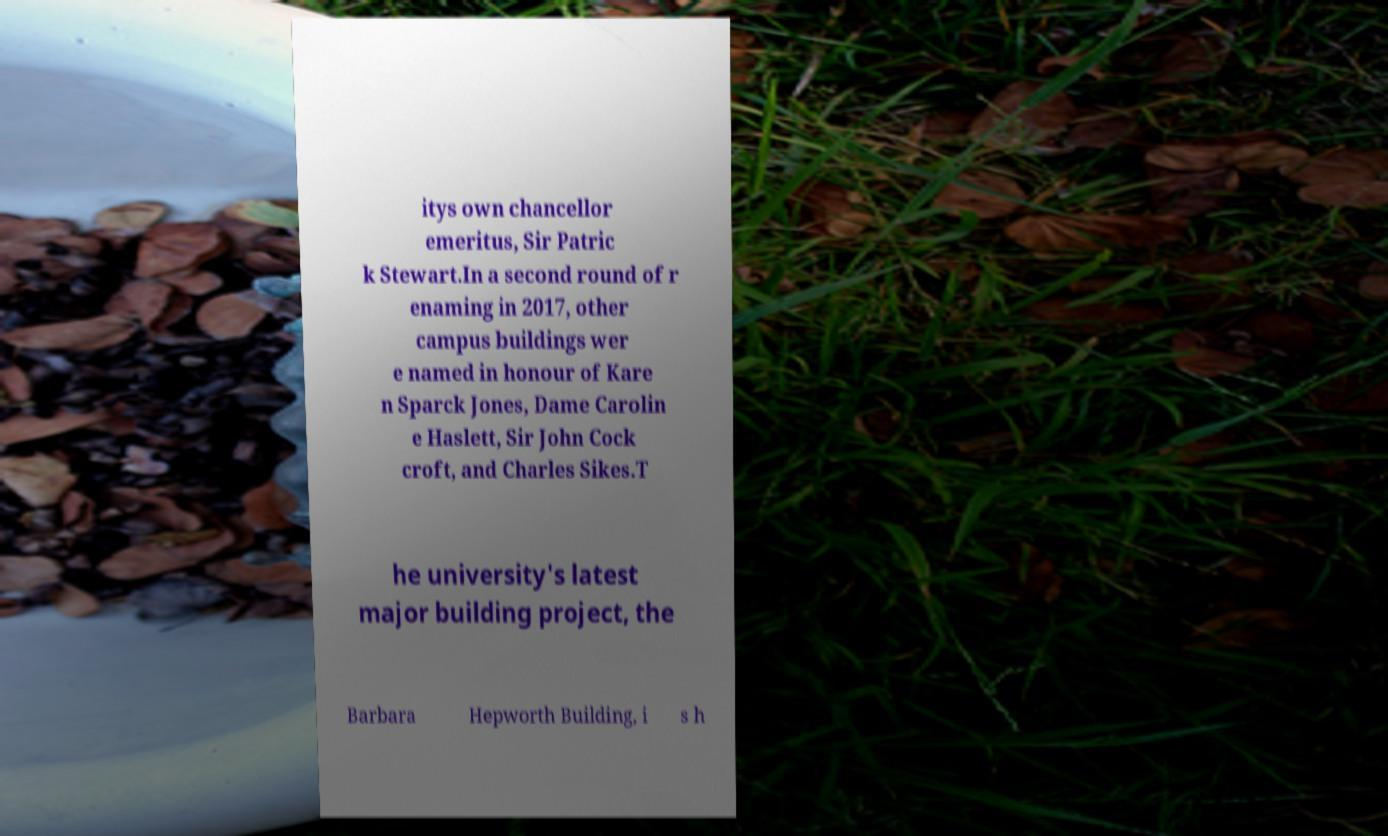For documentation purposes, I need the text within this image transcribed. Could you provide that? itys own chancellor emeritus, Sir Patric k Stewart.In a second round of r enaming in 2017, other campus buildings wer e named in honour of Kare n Sparck Jones, Dame Carolin e Haslett, Sir John Cock croft, and Charles Sikes.T he university's latest major building project, the Barbara Hepworth Building, i s h 